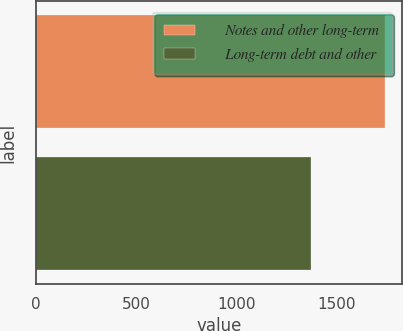Convert chart to OTSL. <chart><loc_0><loc_0><loc_500><loc_500><bar_chart><fcel>Notes and other long-term<fcel>Long-term debt and other<nl><fcel>1740<fcel>1373<nl></chart> 